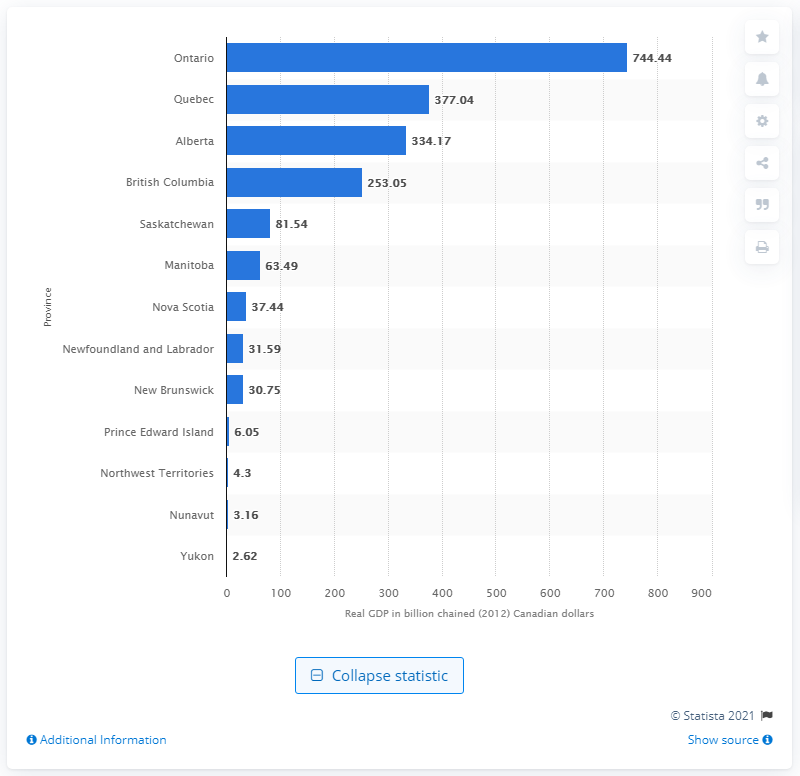List a handful of essential elements in this visual. In 2012, Ontario contributed $744.44 in Canadian dollars to the real GDP of Canada. 